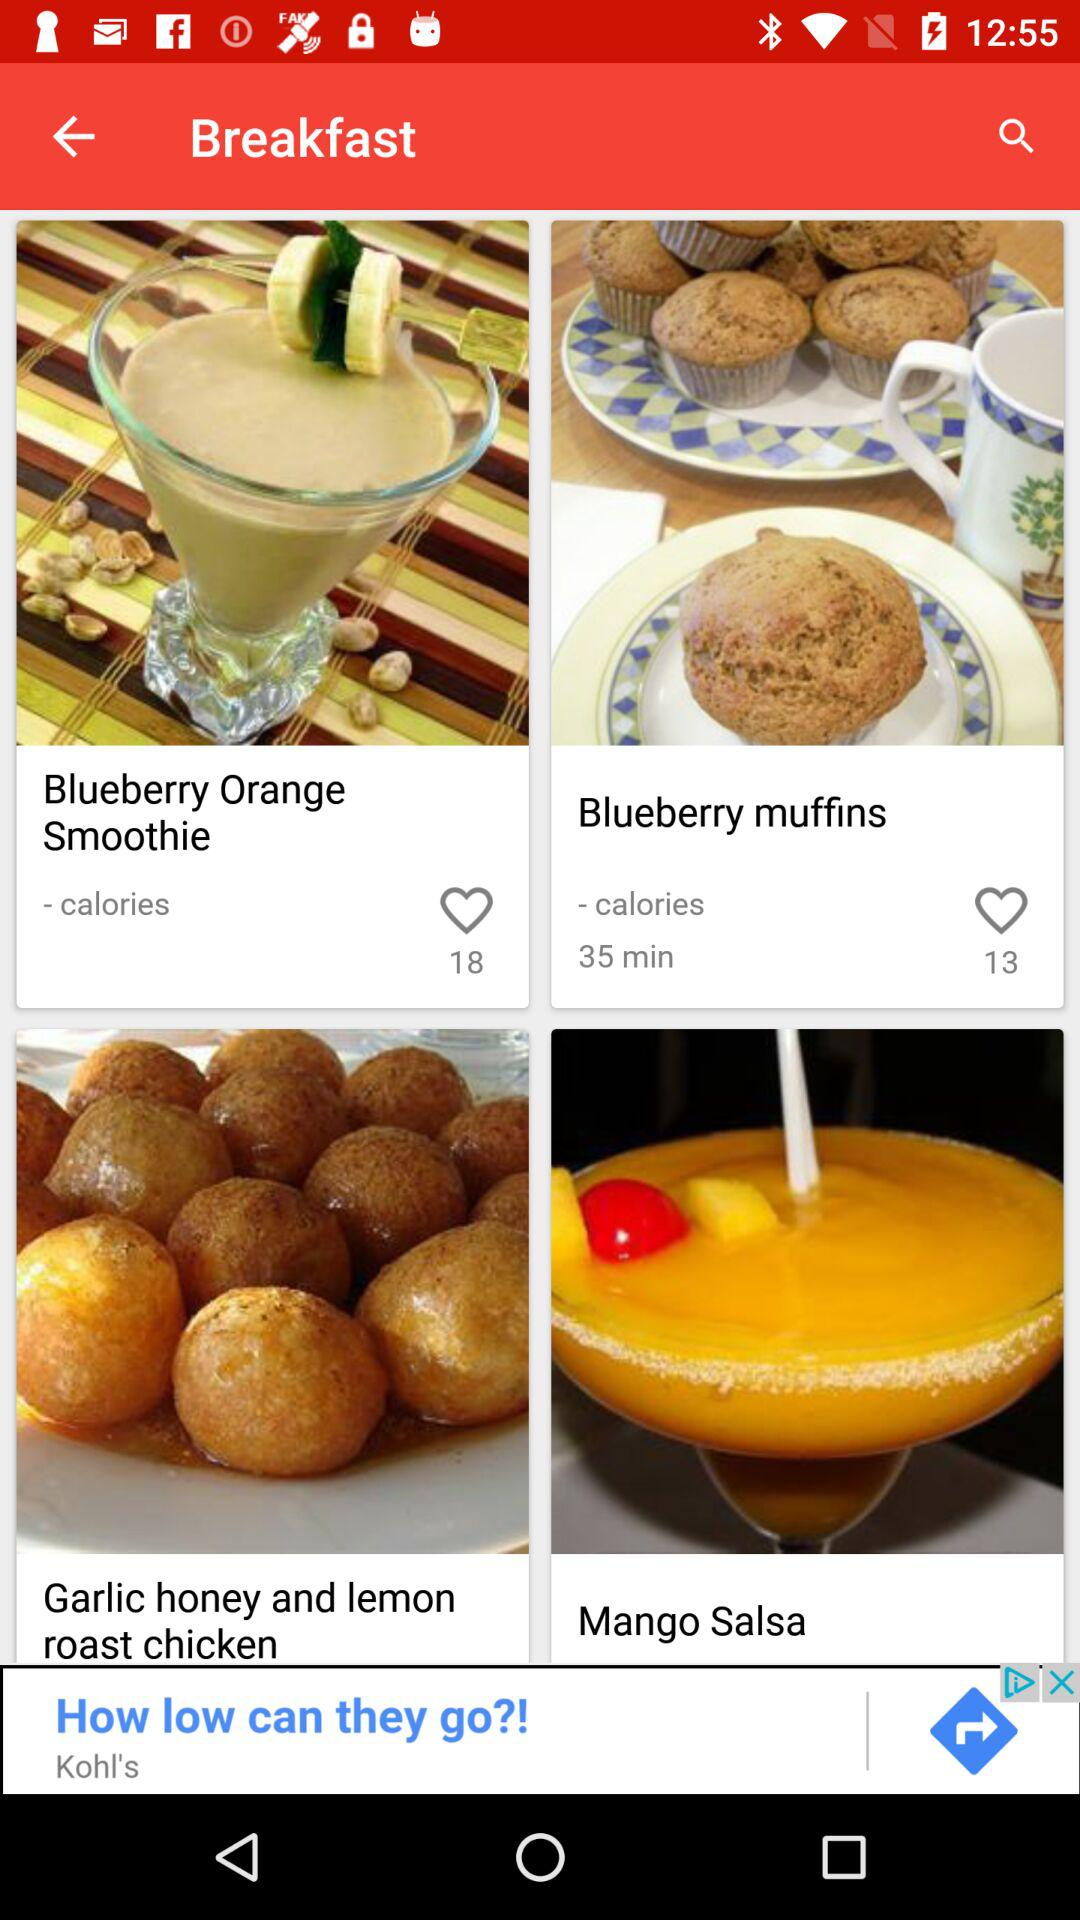How many likes are there for "Blueberry muffins"? There are 13 likes for "Blueberry muffins". 